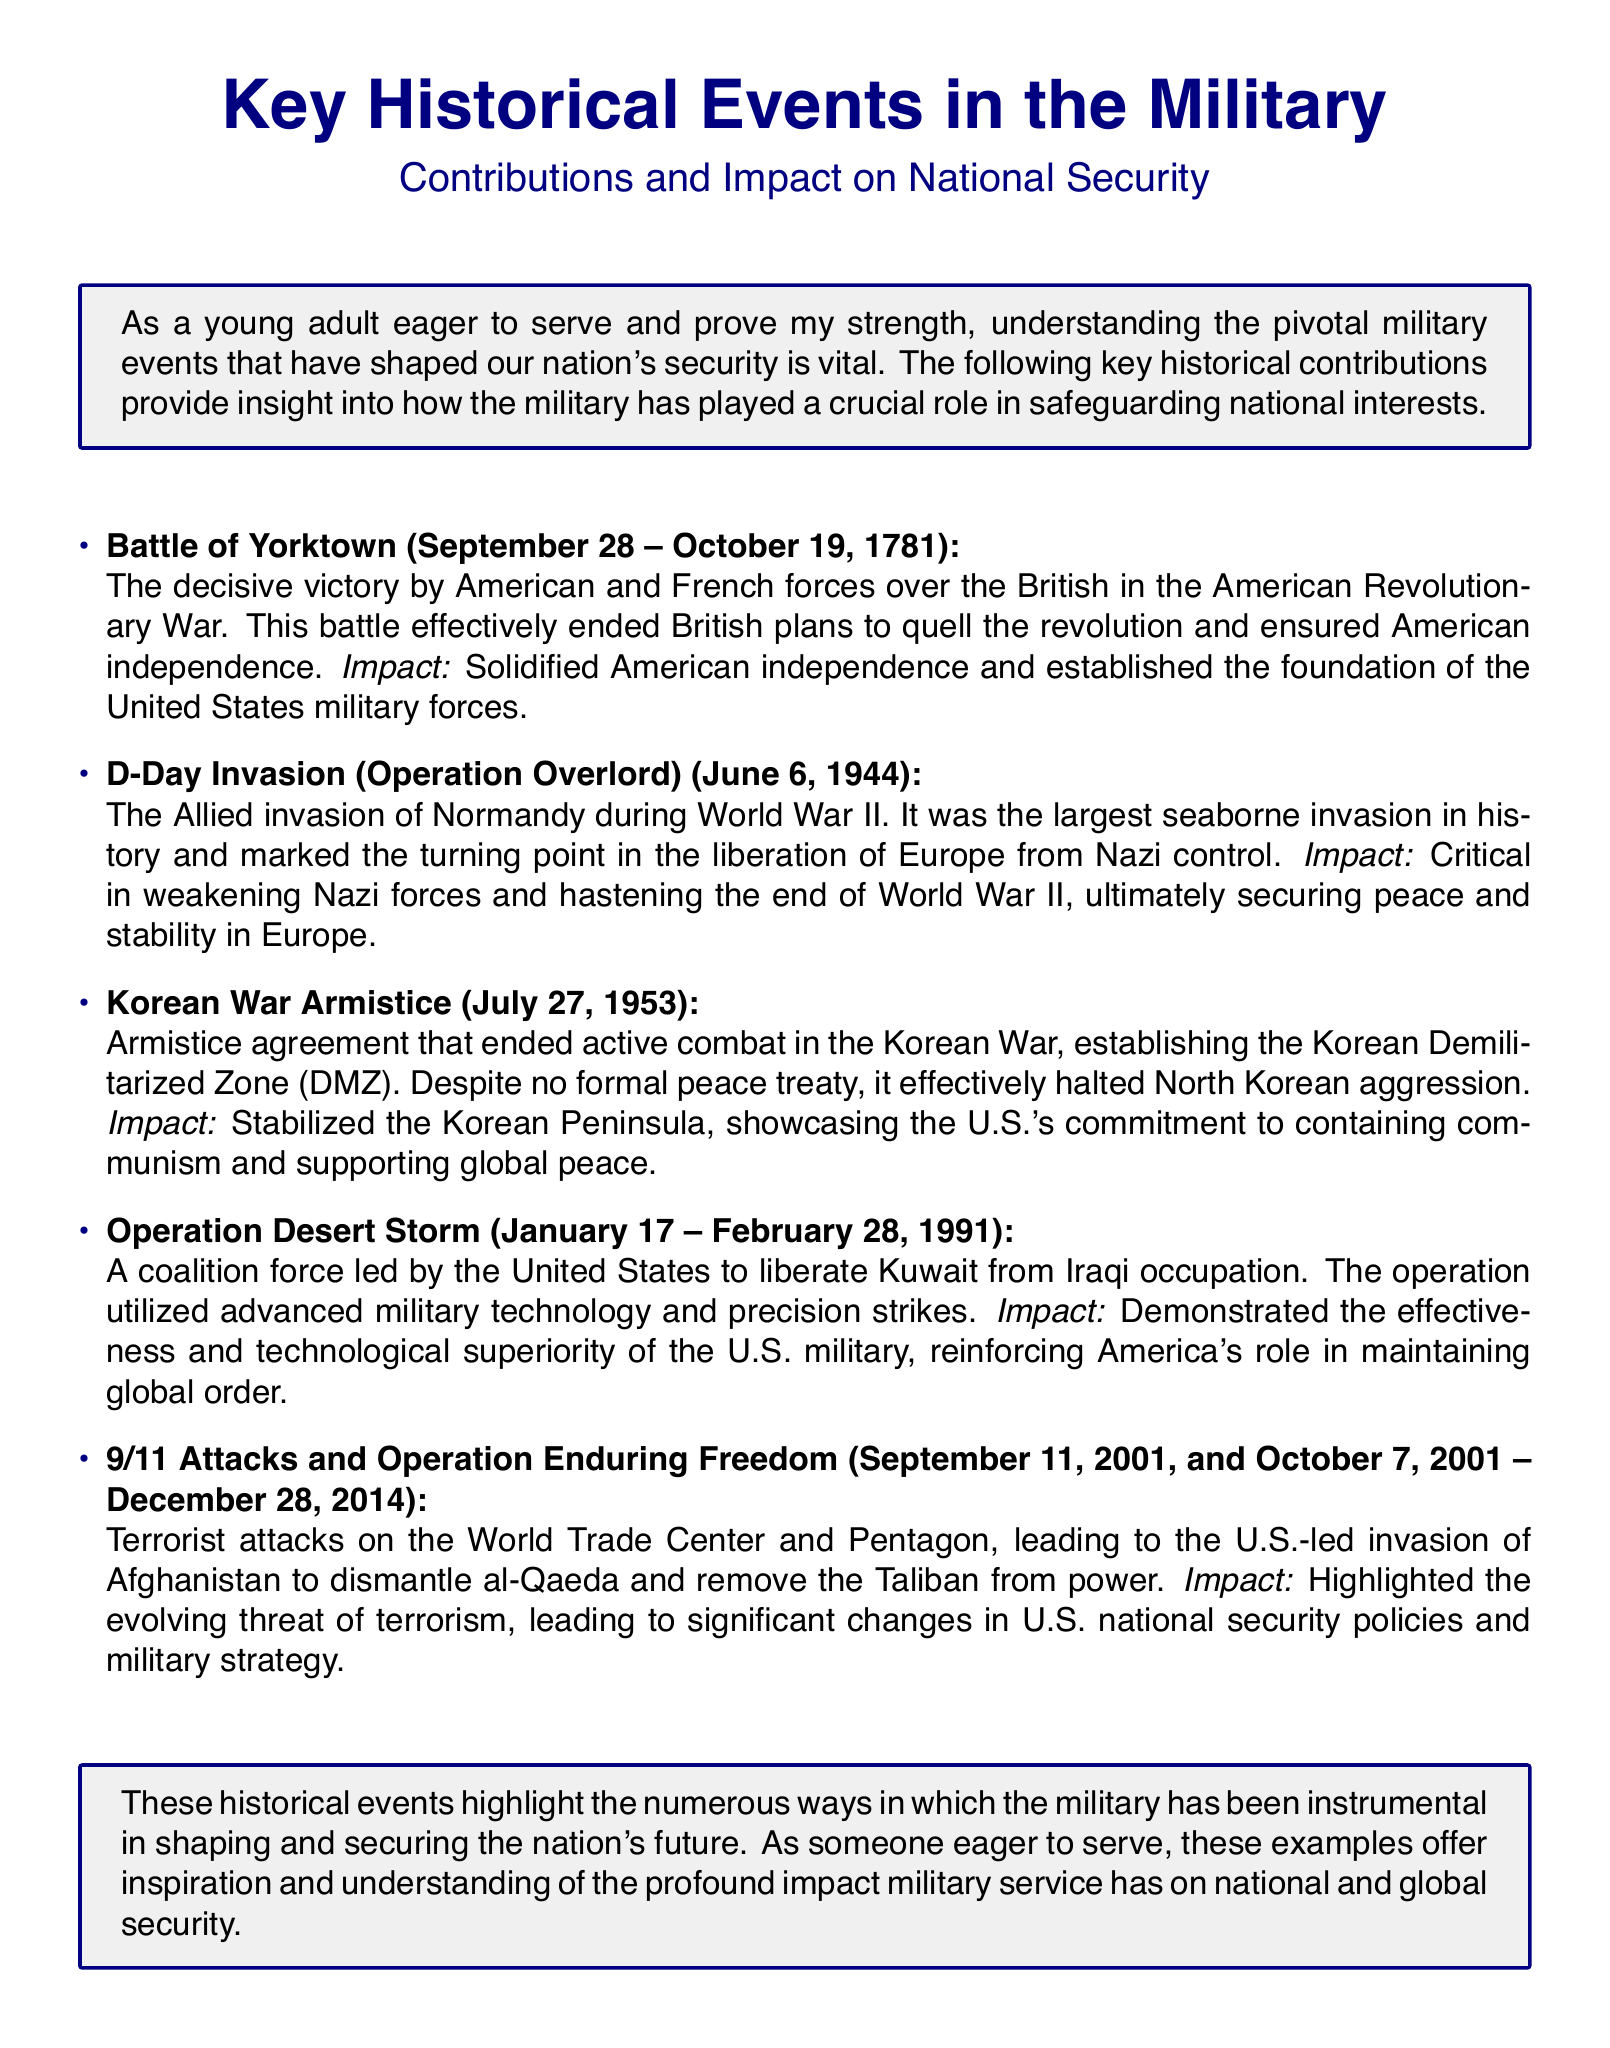What was the decisive victory that ended British plans in the American Revolutionary War? The document states that the Battle of Yorktown was the decisive victory that effectively ended British plans to quell the revolution.
Answer: Battle of Yorktown What significant event occurred on June 6, 1944? According to the document, the D-Day Invasion (Operation Overlord) occurred on June 6, 1944, marking a pivotal moment in World War II.
Answer: D-Day Invasion What agreement ended active combat in the Korean War? The document mentions that the Korean War Armistice was the agreement that ended active combat in the Korean War.
Answer: Korean War Armistice How long did Operation Desert Storm last? The document states that Operation Desert Storm lasted from January 17 to February 28, 1991.
Answer: 43 days What event highlighted the evolving threat of terrorism? The document indicates that the 9/11 Attacks and Operation Enduring Freedom highlighted the evolving threat of terrorism.
Answer: 9/11 Attacks How did the D-Day Invasion impact World War II? The document mentions that the D-Day Invasion was critical in weakening Nazi forces and hastening the end of World War II.
Answer: Weakening Nazi forces What was established by the Korean War Armistice? The document specifies that the Korean Demilitarized Zone (DMZ) was established by the Korean War Armistice.
Answer: Korean Demilitarized Zone What theme is highlighted in the fact sheet's introduction? The document states that understanding pivotal military events is vital for serving and proving strength, highlighting the importance of military contribution to national security.
Answer: Importance of military contribution What technological aspect was demonstrated during Operation Desert Storm? The document emphasizes that Operation Desert Storm demonstrated the effectiveness and technological superiority of the U.S. military.
Answer: Technological superiority 